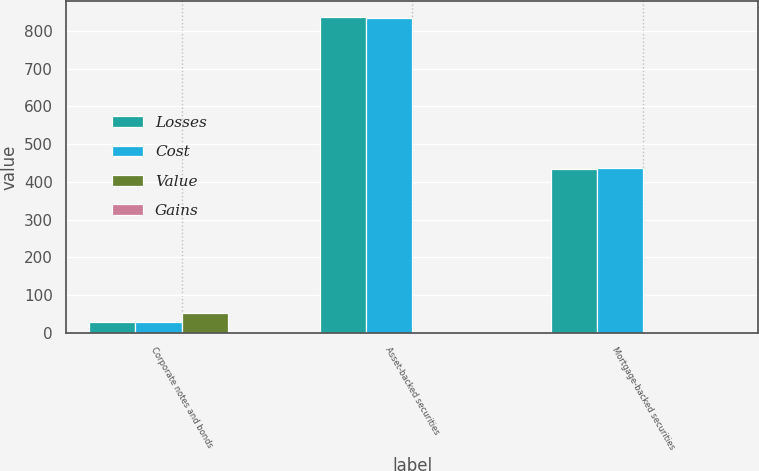<chart> <loc_0><loc_0><loc_500><loc_500><stacked_bar_chart><ecel><fcel>Corporate notes and bonds<fcel>Asset-backed securities<fcel>Mortgage-backed securities<nl><fcel>Losses<fcel>27.5<fcel>837<fcel>435<nl><fcel>Cost<fcel>27.5<fcel>835<fcel>436<nl><fcel>Value<fcel>52<fcel>3<fcel>2<nl><fcel>Gains<fcel>2<fcel>1<fcel>3<nl></chart> 